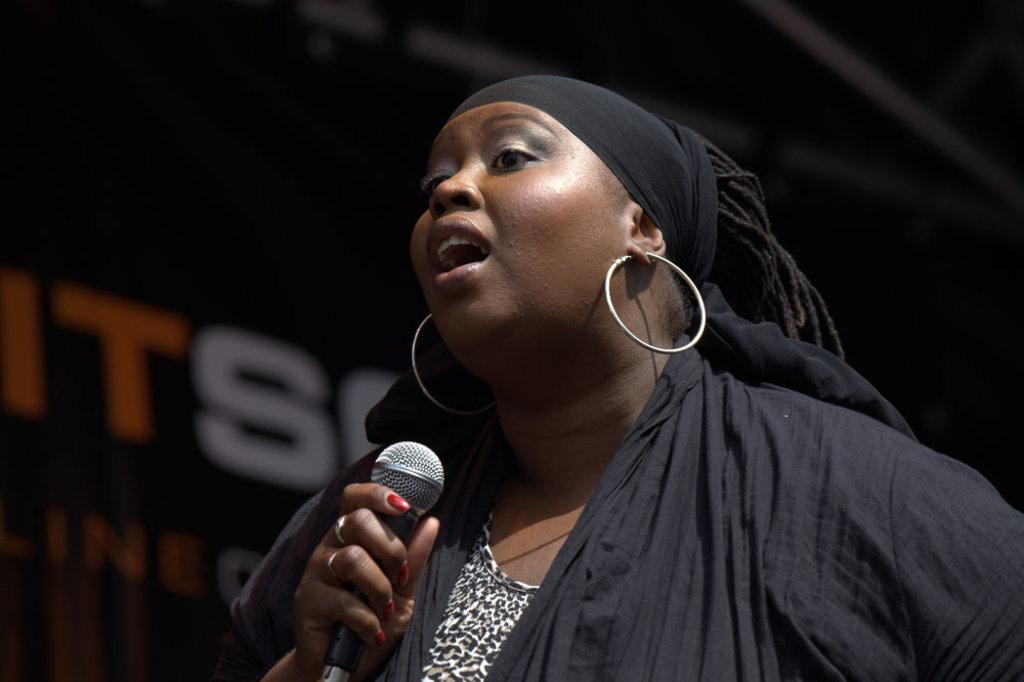Who is the main subject in the image? There is a woman in the image. What is the woman doing in the image? The woman is singing. What object is the woman holding in the image? The woman is holding a microphone. What color is the dress the woman is wearing? The woman is wearing a black dress. Are there any sacks visible in the image? No, there are no sacks present in the image. Can you see any cobwebs in the image? No, there are no cobwebs present in the image. 